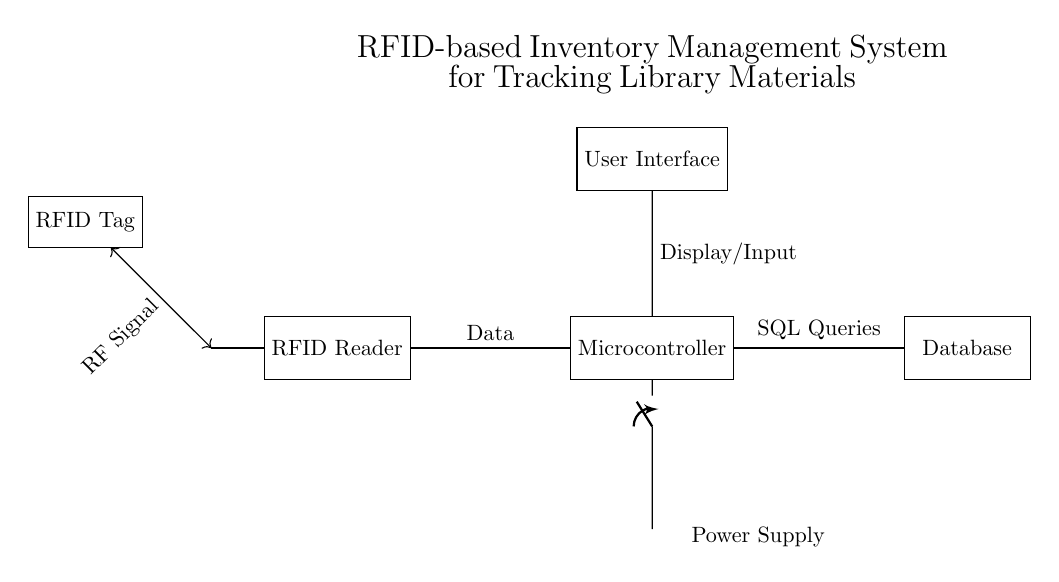What is the function of the RFID reader in the circuit? The RFID reader detects RFID signals from tags, enabling the identification and tracking of items.
Answer: Detecting RFID signals What component acts as the central processing unit? The microcontroller serves as the central processor, handling data from the RFID reader and managing communication with the database and user interface.
Answer: Microcontroller What type of signal is utilized for communication between the RFID tag and the reader? The communication between the RFID tag and the reader occurs via radio frequency signals, which allows for contactless interactions.
Answer: RF Signal How are the RFID reader and microcontroller connected? The RFID reader is connected to the microcontroller through a direct data line, allowing the reader to send detected information for further processing.
Answer: Data What is the purpose of the user interface in the circuit? The user interface allows users to interact with the system, providing a means to display information and input commands related to inventory management.
Answer: User interaction What type of power source is shown in the circuit? The circuit includes a battery, which serves as the power supply to provide the necessary voltage and current for operation.
Answer: Battery Which component interacts with SQL queries? The microcontroller interacts with SQL queries, as it processes the data received from the RFID reader and communicates with the database using structured query language.
Answer: Microcontroller 